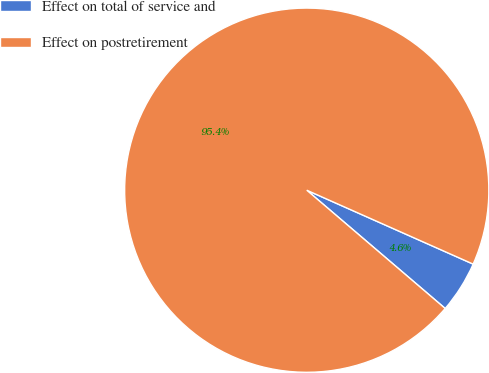<chart> <loc_0><loc_0><loc_500><loc_500><pie_chart><fcel>Effect on total of service and<fcel>Effect on postretirement<nl><fcel>4.6%<fcel>95.4%<nl></chart> 